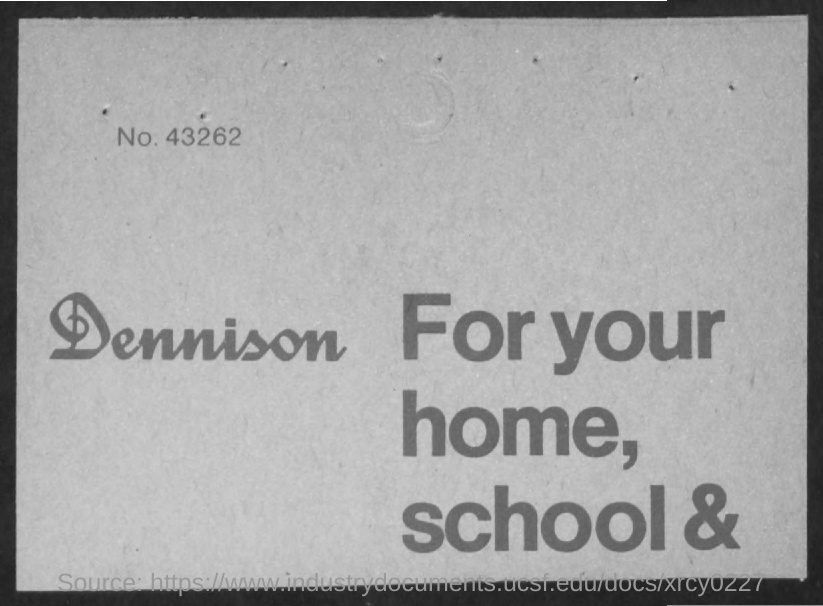Mention a couple of crucial points in this snapshot. The number is 43,262. 